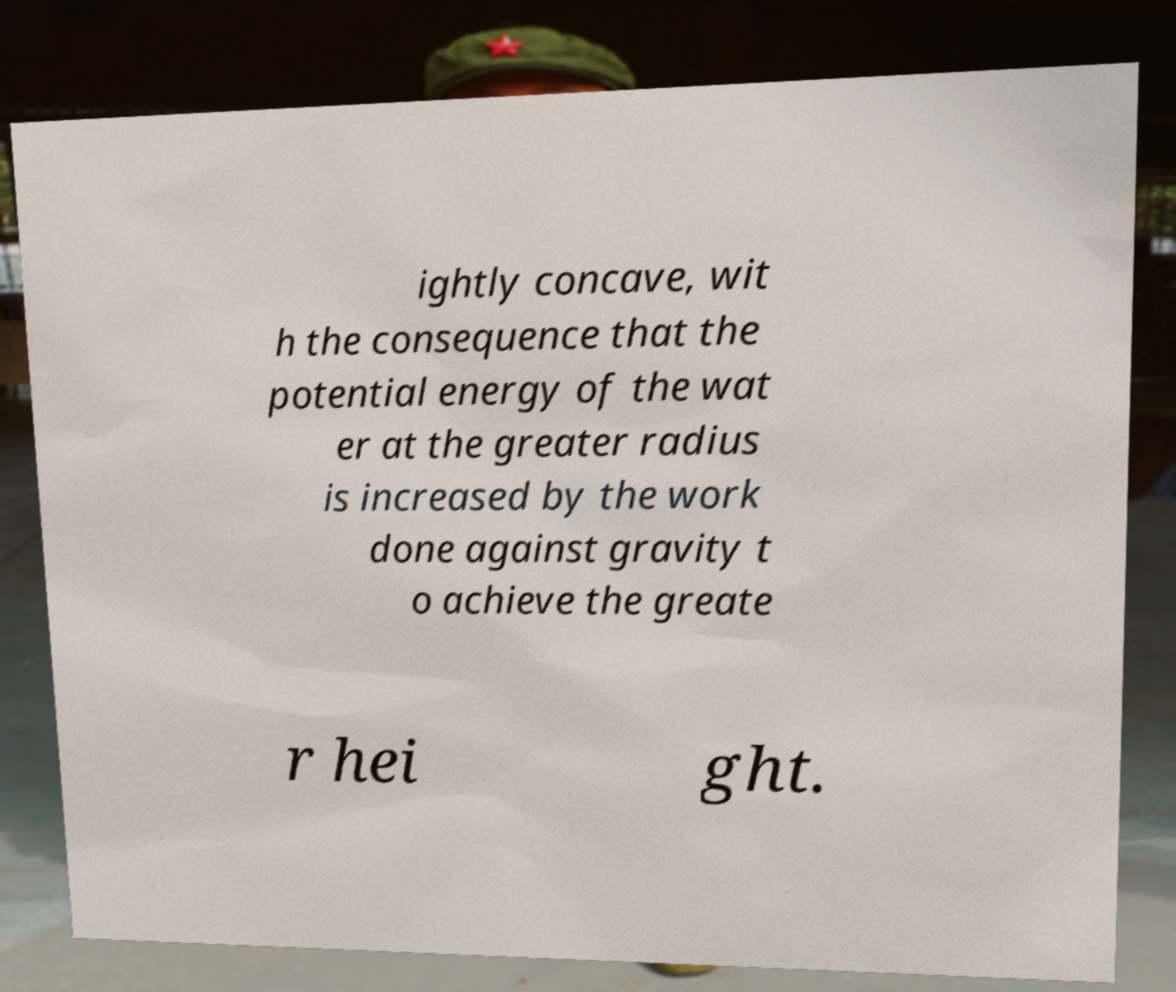For documentation purposes, I need the text within this image transcribed. Could you provide that? ightly concave, wit h the consequence that the potential energy of the wat er at the greater radius is increased by the work done against gravity t o achieve the greate r hei ght. 